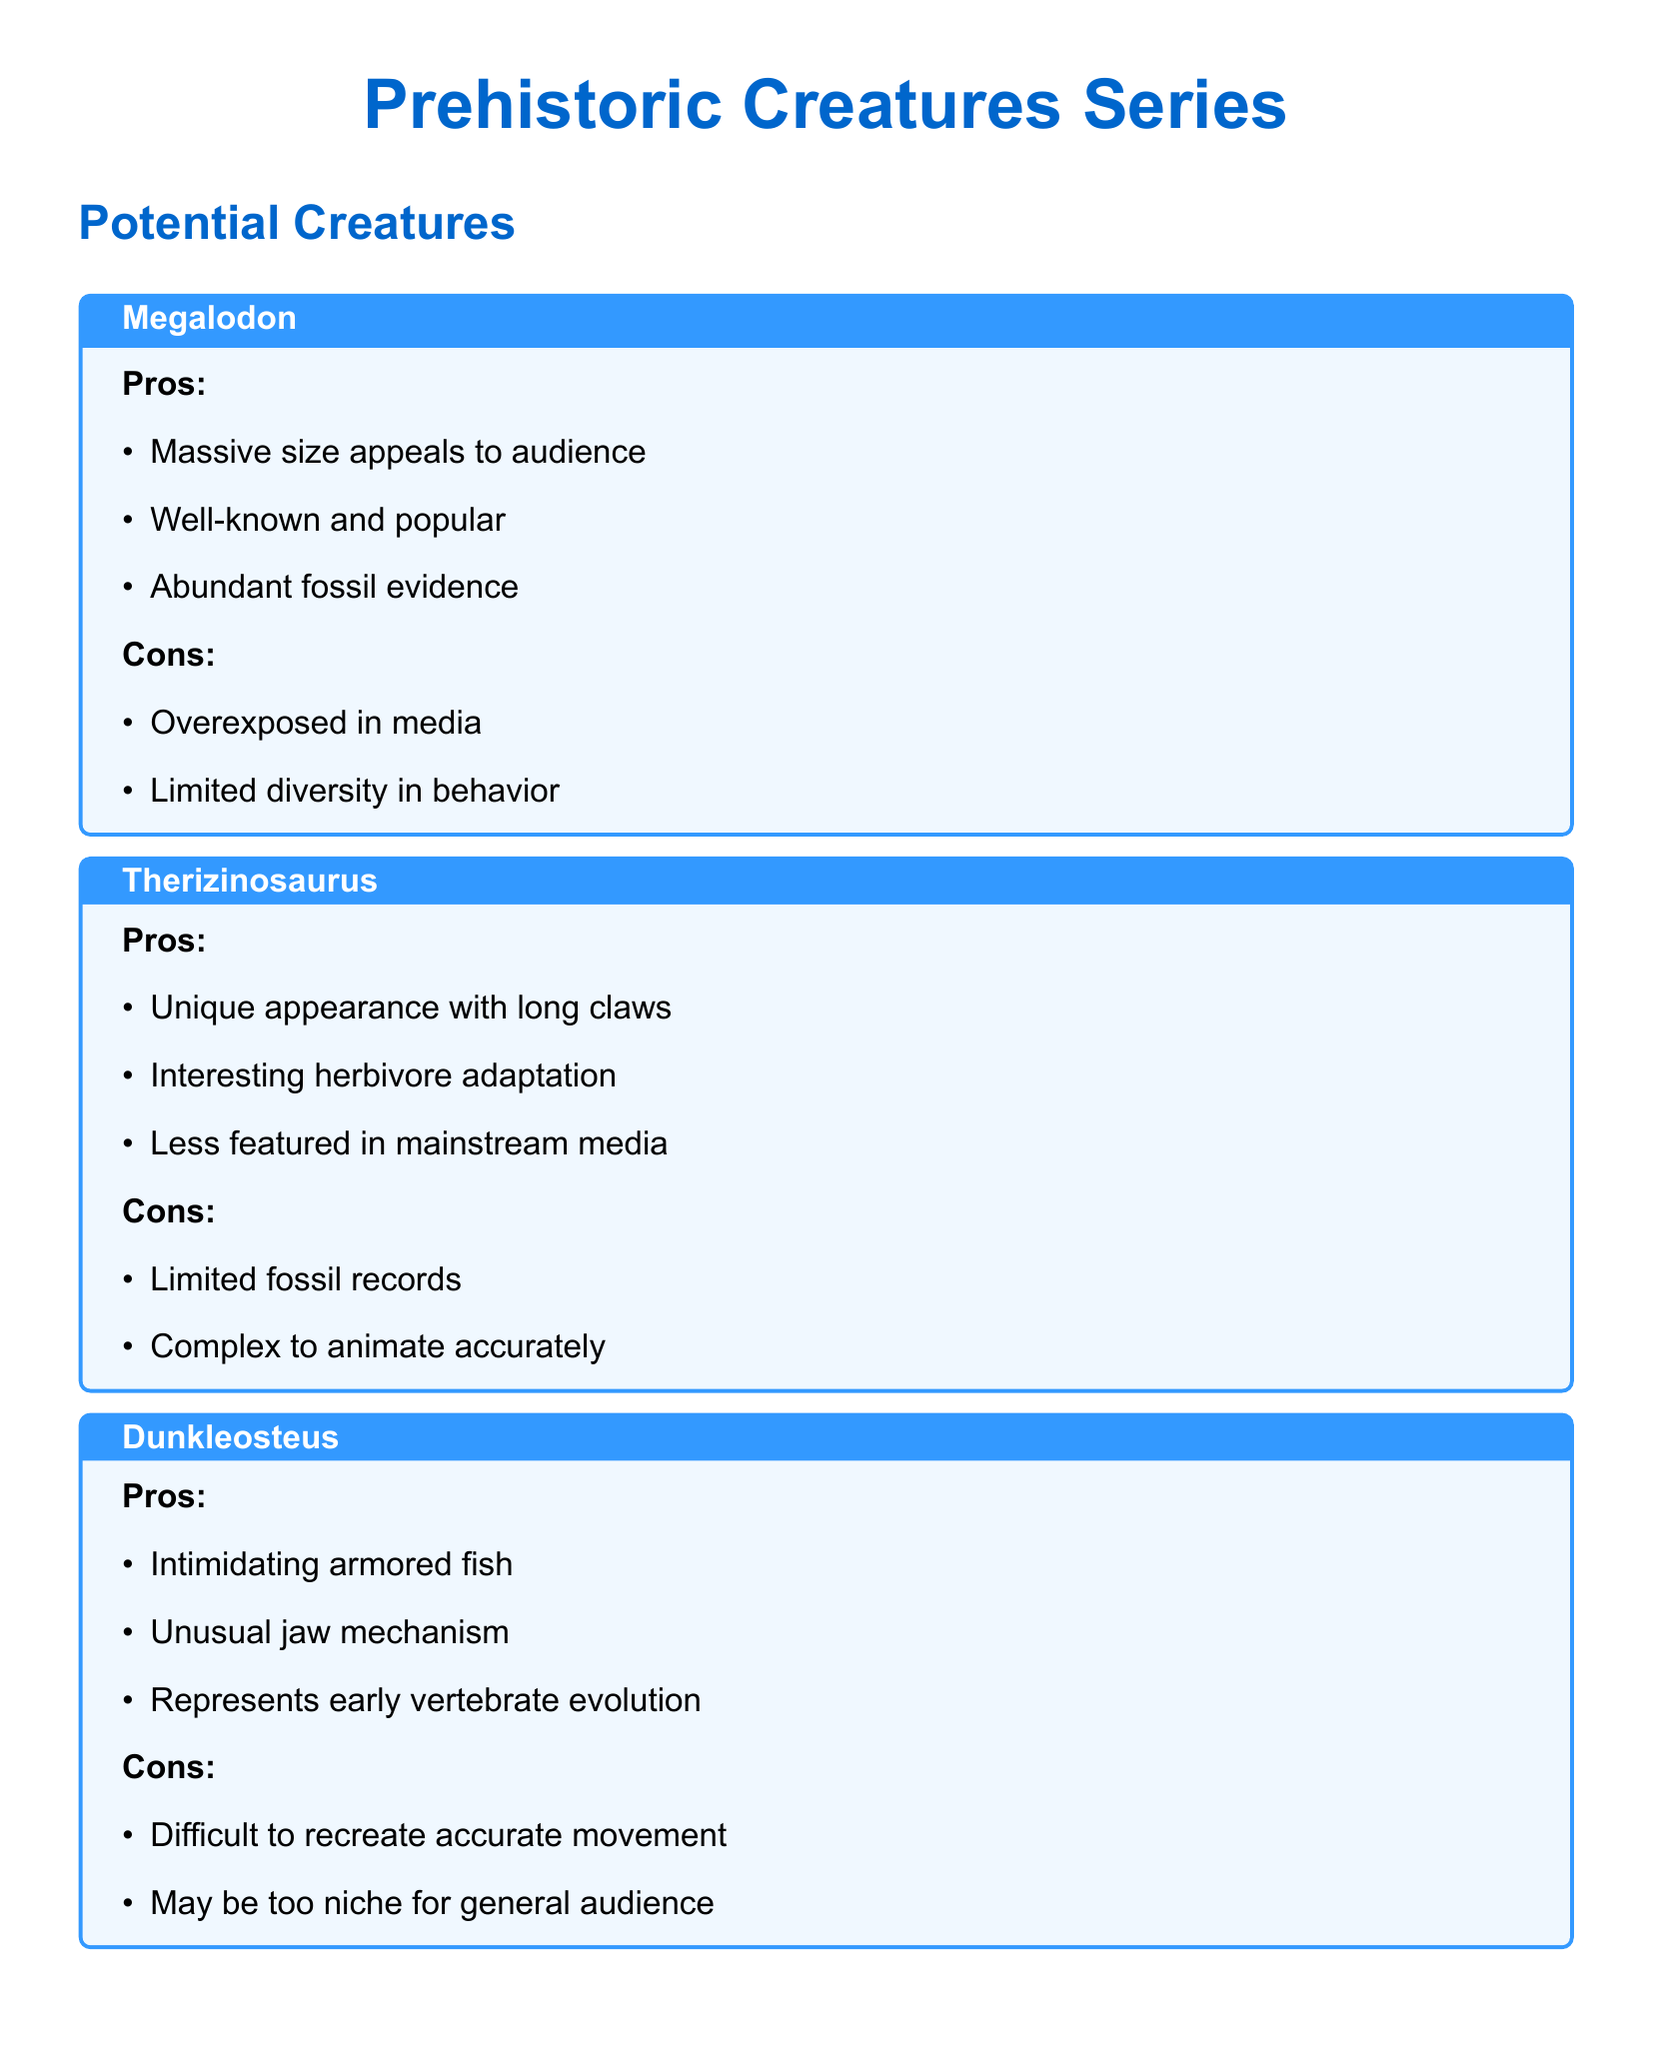What is the name of the largest known flying animal? The document lists Quetzalcoatlus as the largest known flying animal.
Answer: Quetzalcoatlus Which creature is noted for its unique appearance with long claws? The Therizinosaurus is mentioned for its unique appearance with long claws.
Answer: Therizinosaurus How many pros are listed for Dunkleosteus? The pros listed for Dunkleosteus include three points in the document.
Answer: three What is a con of Protoceratops regarding its size? The document states that the smaller size of Protoceratops may be less impactful as a con.
Answer: less impactful Which creature has limited fossil records? The document indicates that Therizinosaurus has limited fossil records.
Answer: Therizinosaurus What is one particular consideration mentioned for balancing prehistoric creatures? The document mentions balancing between land, sea, and air creatures as a consideration.
Answer: land, sea, and air creatures Which prehistoric creature is described as an intimidating armored fish? Dunkleosteus is described as an intimidating armored fish in the document.
Answer: Dunkleosteus Which creature is characterized by an unusual jaw mechanism? The document identifies Dunkleosteus as having an unusual jaw mechanism.
Answer: Dunkleosteus What aspect of Quetzalcoatlus is described as challenging? The document states that accurately depicting flight is challenging for Quetzalcoatlus.
Answer: accurately depict flight 